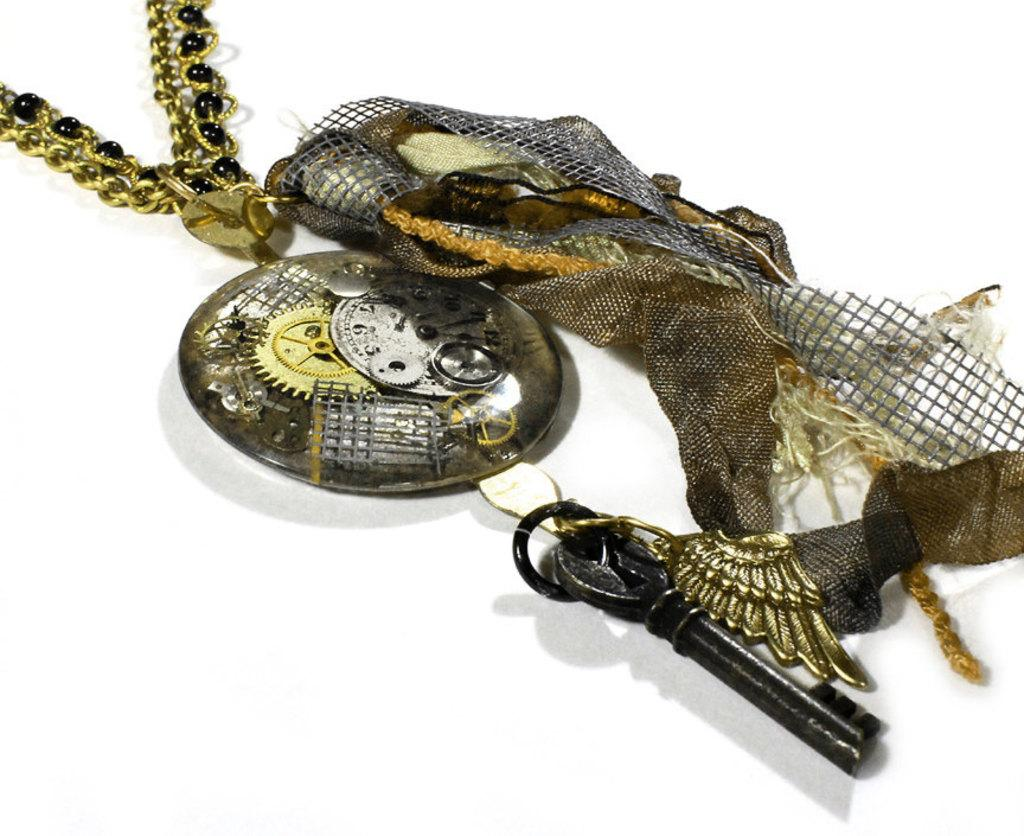What object can be seen in the image that is often used for unlocking doors? There is a key in the image. What type of material is present in the image that can be used for cleaning or covering? There is a cloth in the image. What type of object is present in the image that is typically used for connecting or securing items? There is a chain in the image. What color is the background of the image? The background of the image is white. Can you see any veins in the image? There are no veins present in the image. Is there a swing visible in the image? There is no swing present in the image. 